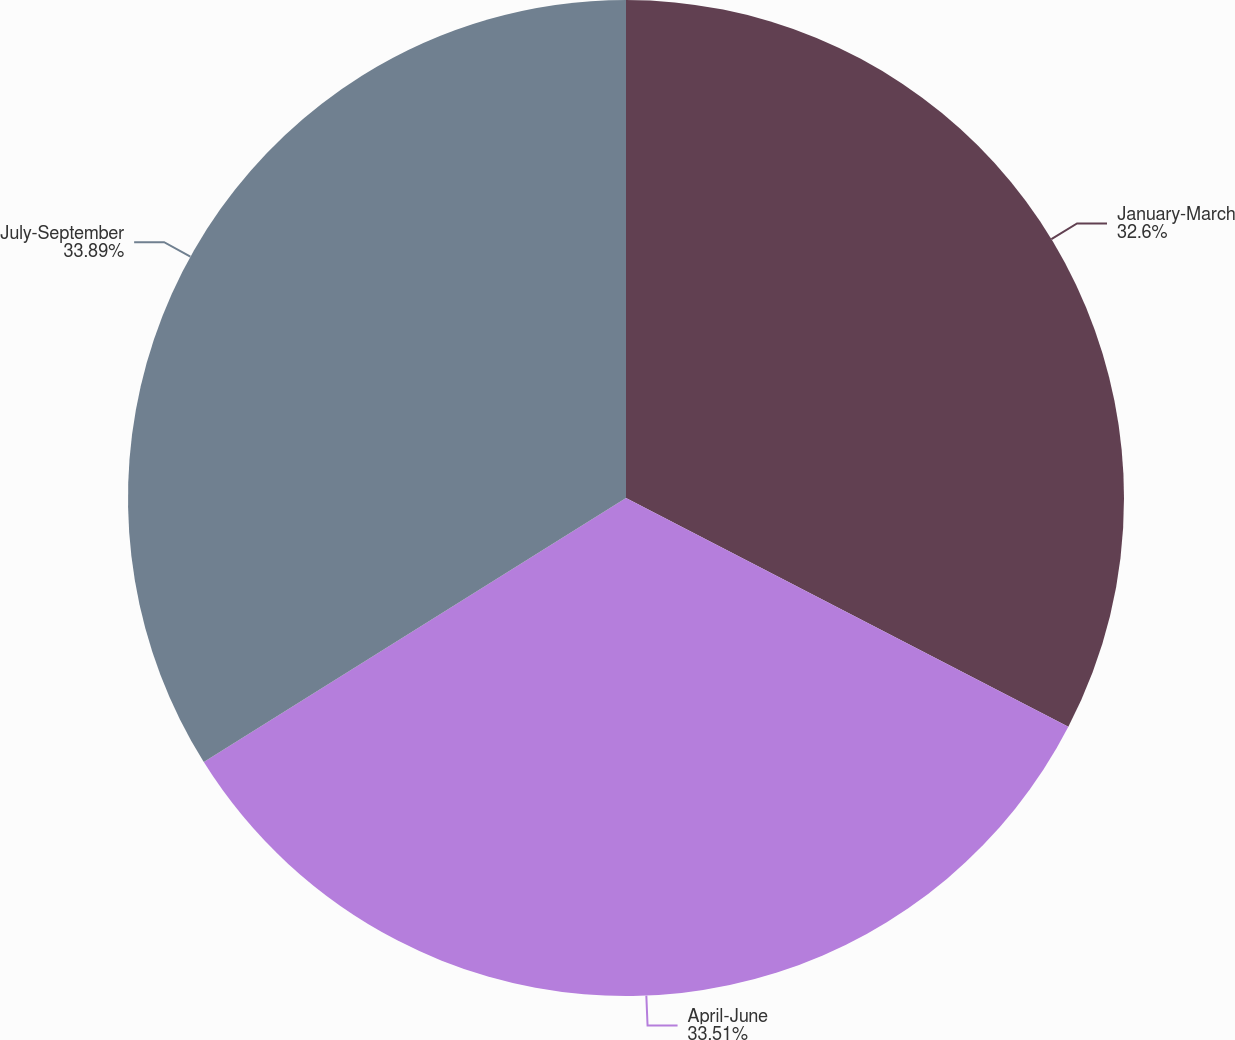Convert chart. <chart><loc_0><loc_0><loc_500><loc_500><pie_chart><fcel>January-March<fcel>April-June<fcel>July-September<nl><fcel>32.6%<fcel>33.51%<fcel>33.9%<nl></chart> 